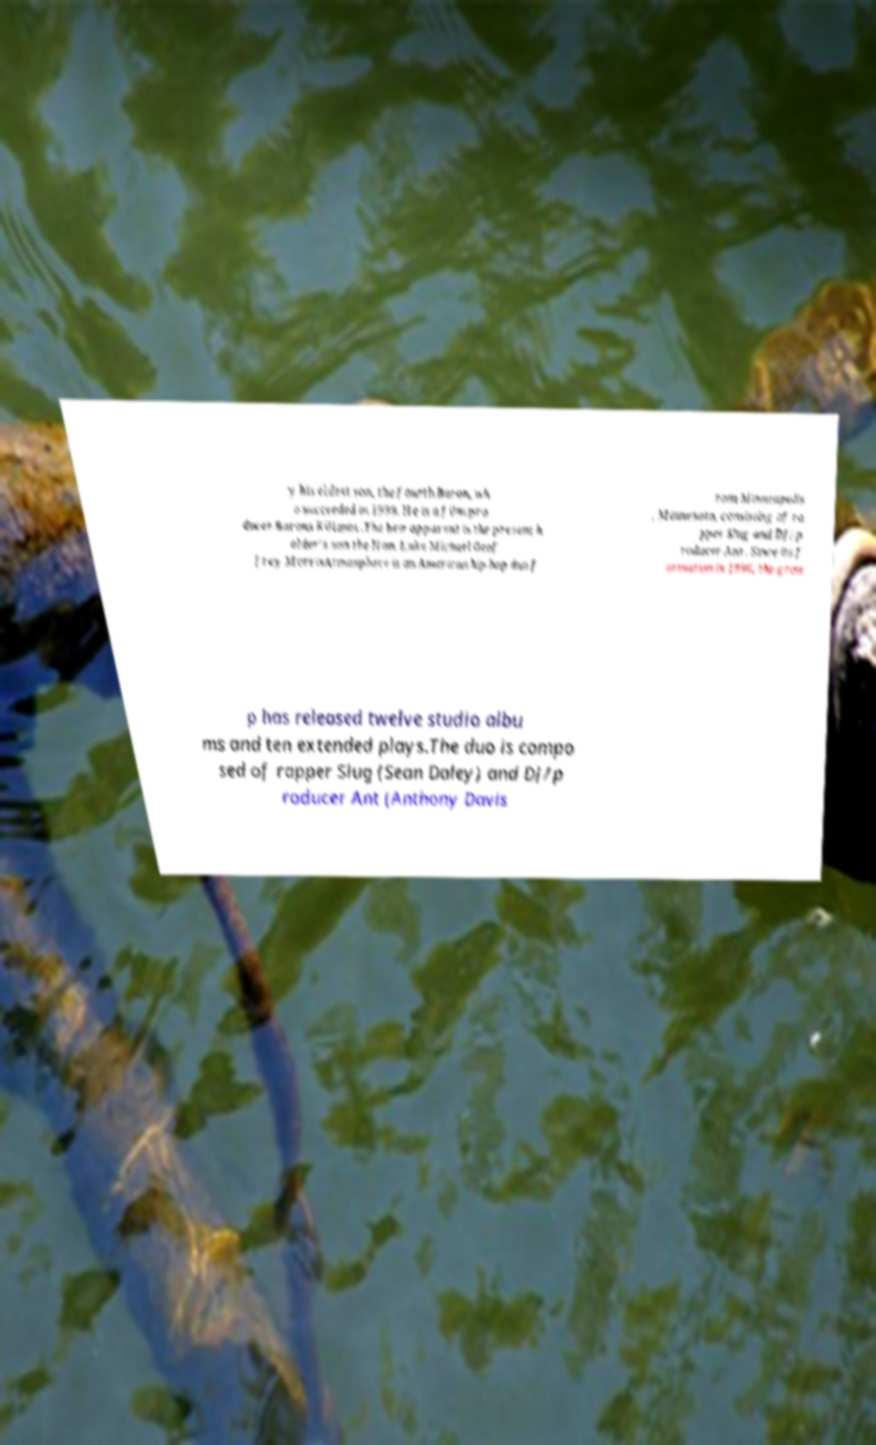Could you extract and type out the text from this image? y his eldest son, the fourth Baron, wh o succeeded in 1999. He is a film pro ducer.Barons Killanin .The heir apparent is the present h older's son the Hon. Luke Michael Geof frey MorrisAtmosphere is an American hip hop duo f rom Minneapolis , Minnesota, consisting of ra pper Slug and DJ/p roducer Ant . Since its f ormation in 1996, the grou p has released twelve studio albu ms and ten extended plays.The duo is compo sed of rapper Slug (Sean Daley) and DJ/p roducer Ant (Anthony Davis 